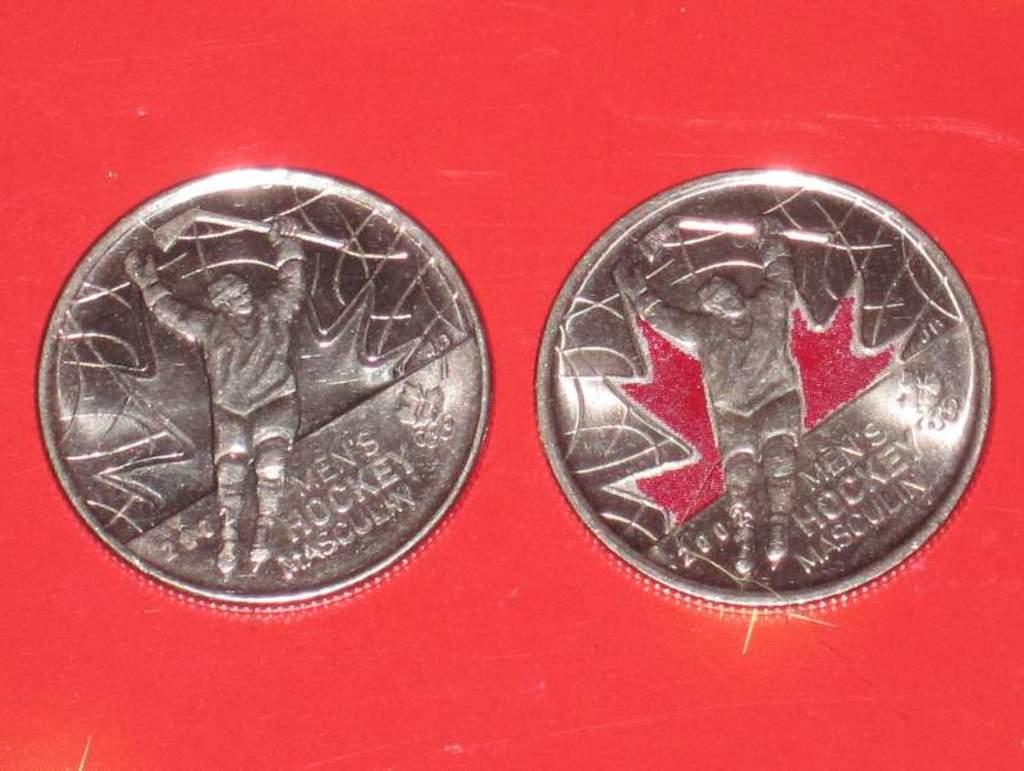What objects can be seen in the image? There are coins in the image. What color is the background of the image? The background of the image is red. What is being depicted in the image? There is a depiction in the image. Are there any words or letters in the image? Yes, there is text in the image. Where is the pig located in the image? There is no pig present in the image. What type of property does the image represent? The image does not represent any specific property. 